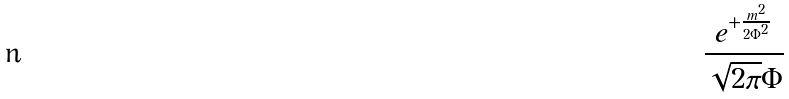Convert formula to latex. <formula><loc_0><loc_0><loc_500><loc_500>\frac { e ^ { + \frac { m ^ { 2 } } { 2 \Phi ^ { 2 } } } } { \sqrt { 2 \pi } \Phi }</formula> 